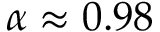Convert formula to latex. <formula><loc_0><loc_0><loc_500><loc_500>\alpha \approx 0 . 9 8</formula> 